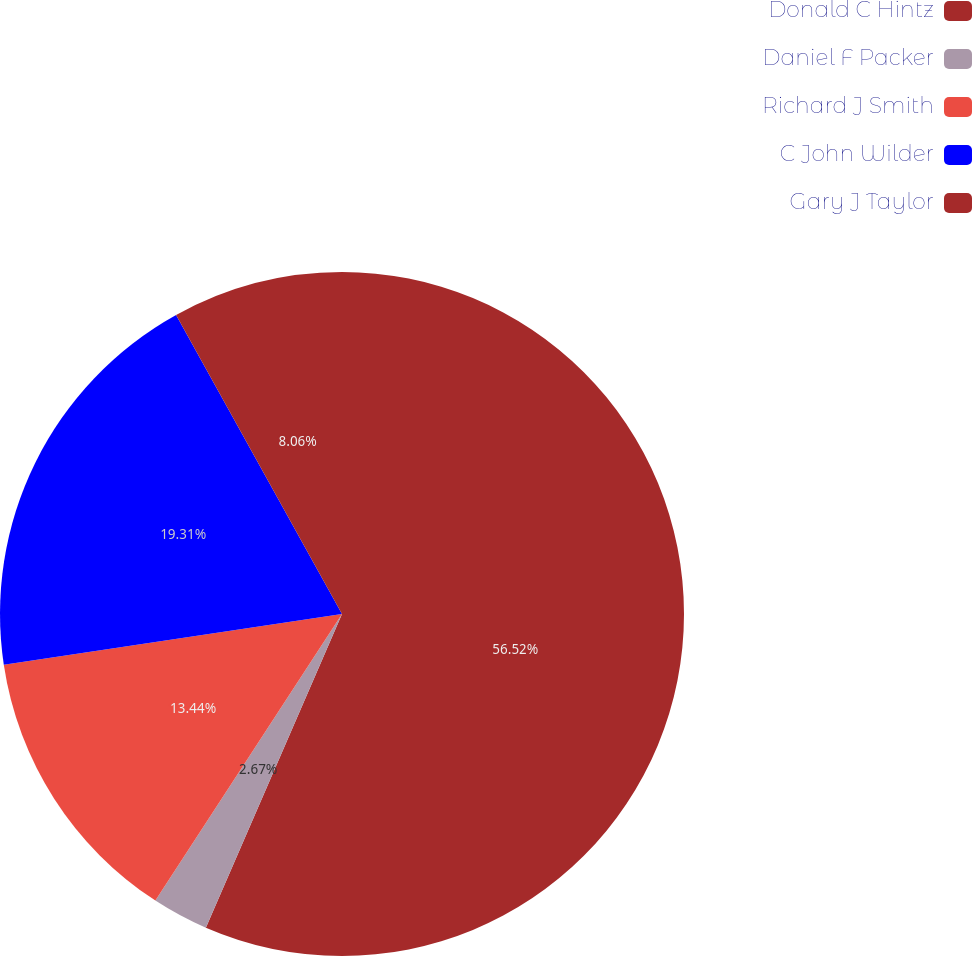Convert chart. <chart><loc_0><loc_0><loc_500><loc_500><pie_chart><fcel>Donald C Hintz<fcel>Daniel F Packer<fcel>Richard J Smith<fcel>C John Wilder<fcel>Gary J Taylor<nl><fcel>56.51%<fcel>2.67%<fcel>13.44%<fcel>19.31%<fcel>8.06%<nl></chart> 